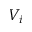Convert formula to latex. <formula><loc_0><loc_0><loc_500><loc_500>V _ { i }</formula> 